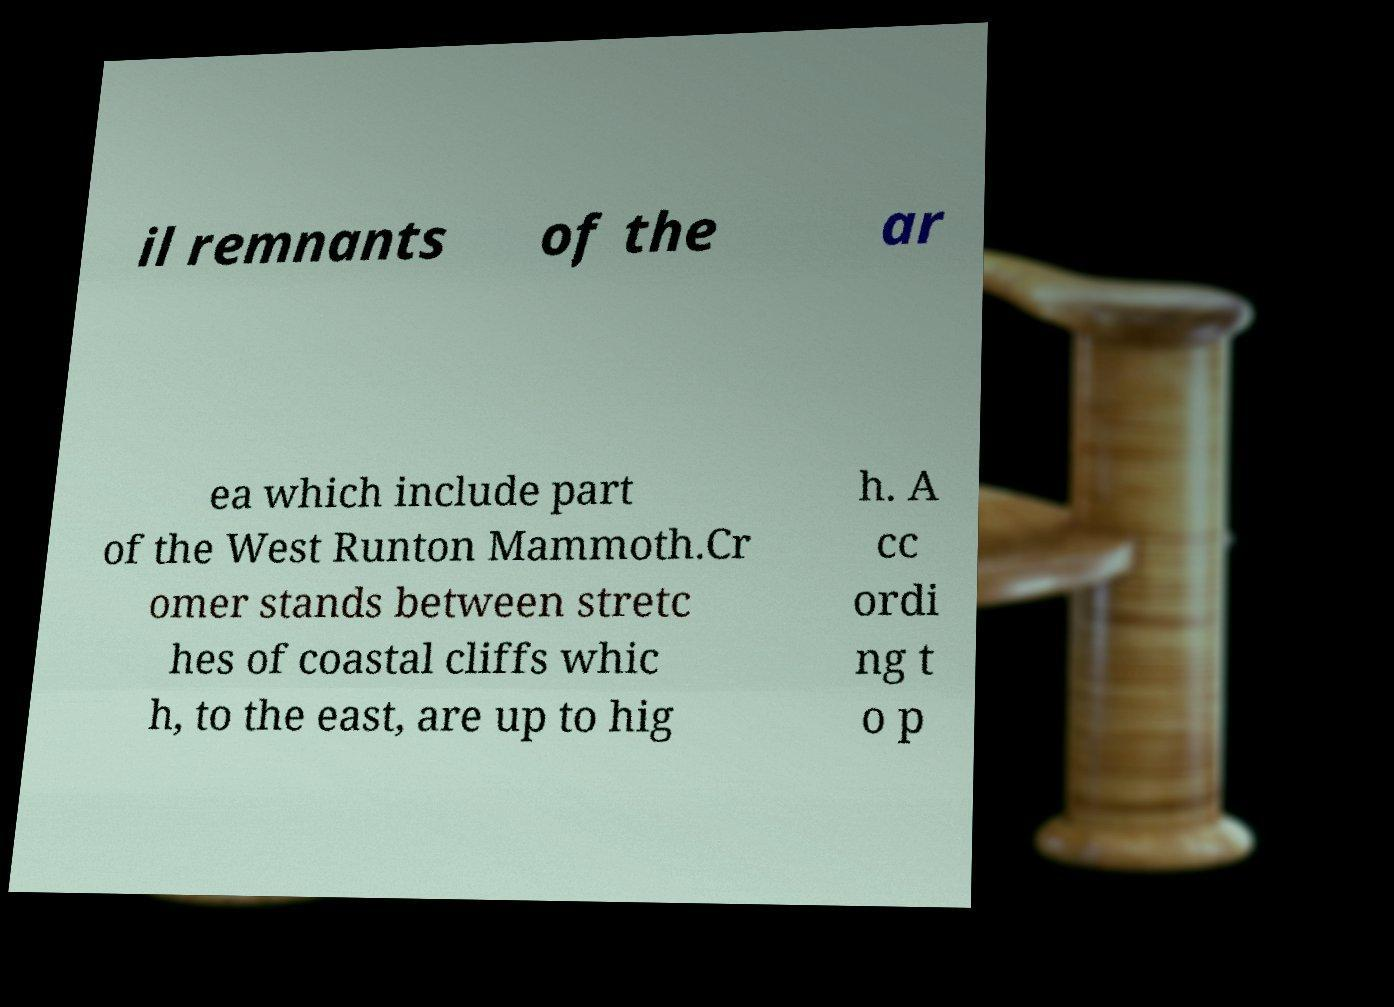Could you extract and type out the text from this image? il remnants of the ar ea which include part of the West Runton Mammoth.Cr omer stands between stretc hes of coastal cliffs whic h, to the east, are up to hig h. A cc ordi ng t o p 